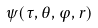<formula> <loc_0><loc_0><loc_500><loc_500>\psi ( \tau , \theta , \varphi , r )</formula> 